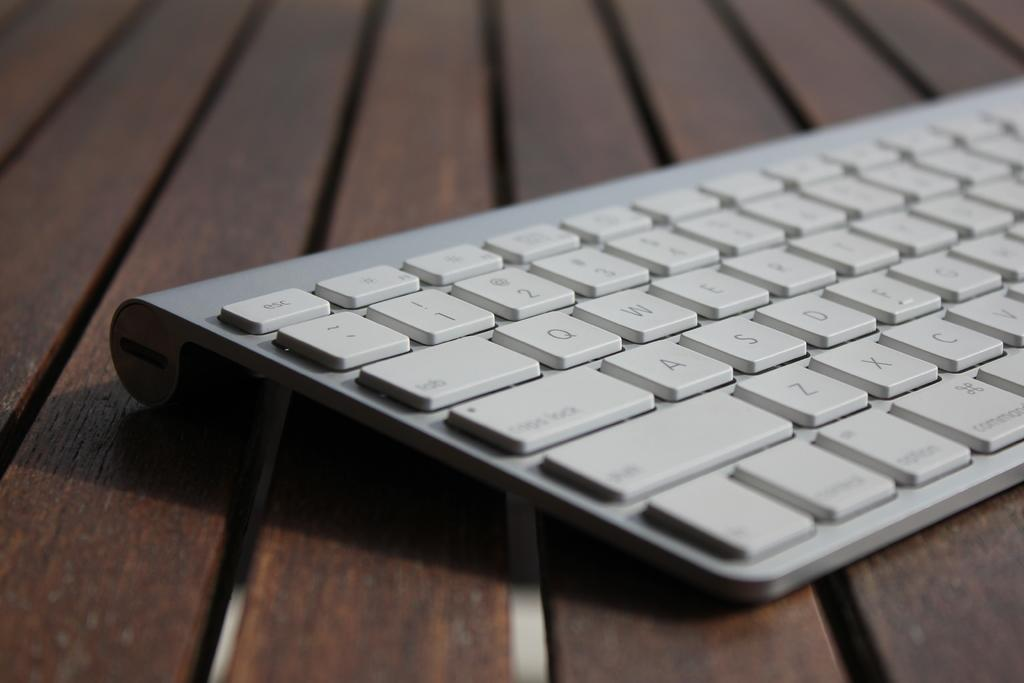Provide a one-sentence caption for the provided image. A close up of a sliver keyboard from the capslock side. 